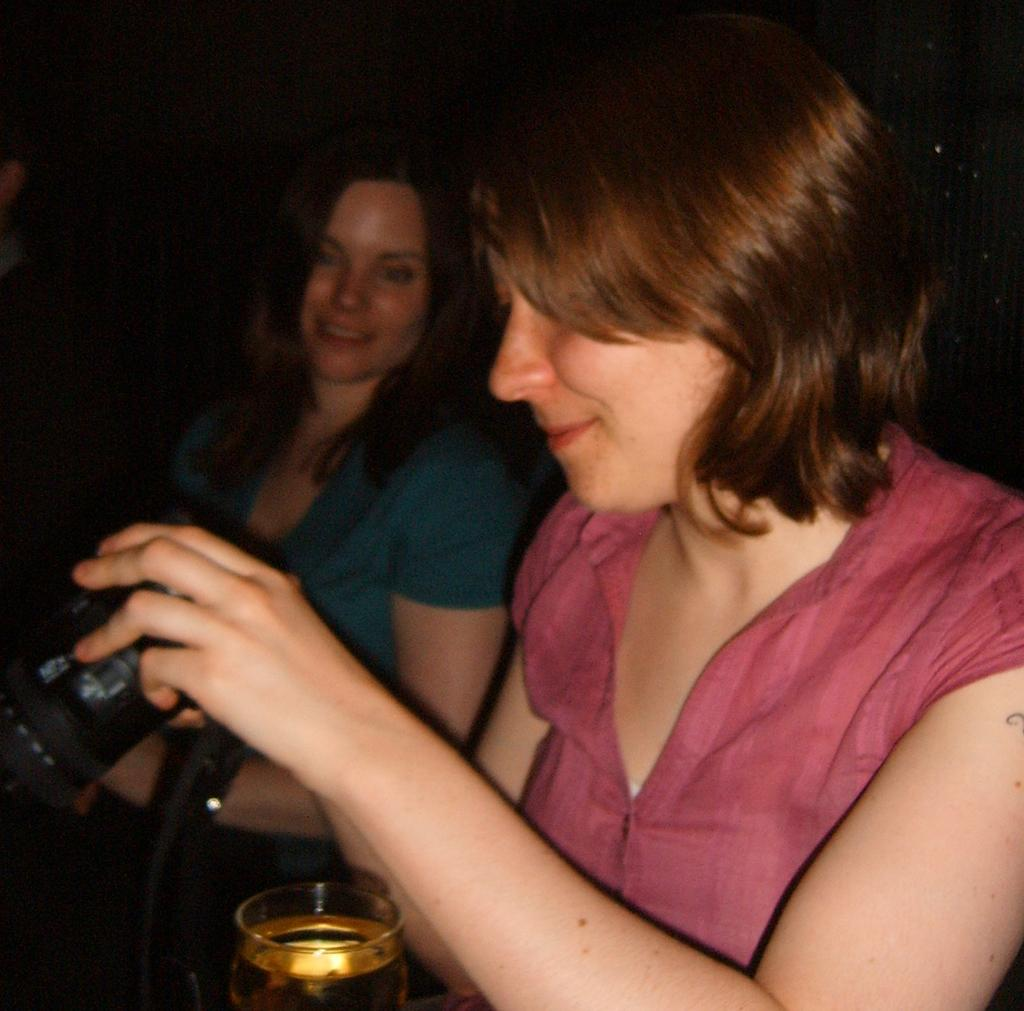How many people are present in the image? There are two people in the image. What object is visible in the image that is commonly used for capturing photos? There is a camera in the image. What type of glassware can be seen in the image? There is a wine glass in the image. What type of bulb is being used to light up the cattle in the image? There are no cattle or bulbs present in the image. What type of canvas is being used to paint the scene in the image? There is no canvas or painting present in the image. 